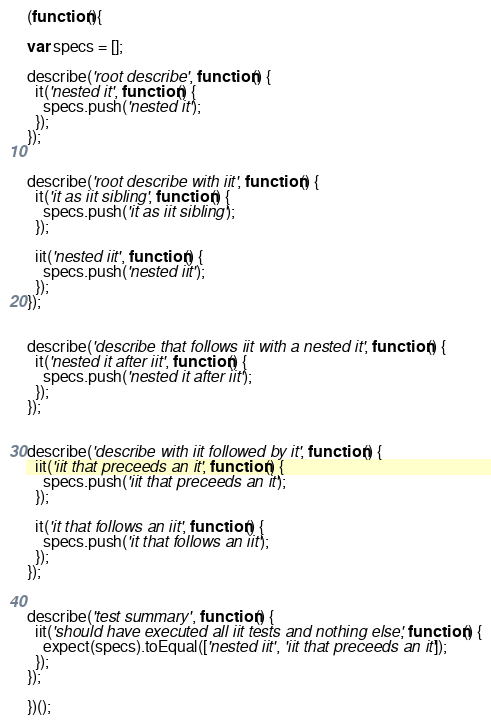Convert code to text. <code><loc_0><loc_0><loc_500><loc_500><_JavaScript_>(function(){

var specs = [];

describe('root describe', function() {
  it('nested it', function() {
    specs.push('nested it');
  });
});


describe('root describe with iit', function() {
  it('it as iit sibling', function() {
    specs.push('it as iit sibling');
  });

  iit('nested iit', function() {
    specs.push('nested iit');
  });
});


describe('describe that follows iit with a nested it', function() {
  it('nested it after iit', function() {
    specs.push('nested it after iit');
  });
});


describe('describe with iit followed by it', function() {
  iit('iit that preceeds an it', function() {
    specs.push('iit that preceeds an it');
  });

  it('it that follows an iit', function() {
    specs.push('it that follows an iit');
  });
});


describe('test summary', function() {
  iit('should have executed all iit tests and nothing else', function() {
    expect(specs).toEqual(['nested iit', 'iit that preceeds an it']);
  });
});	
	
})();</code> 